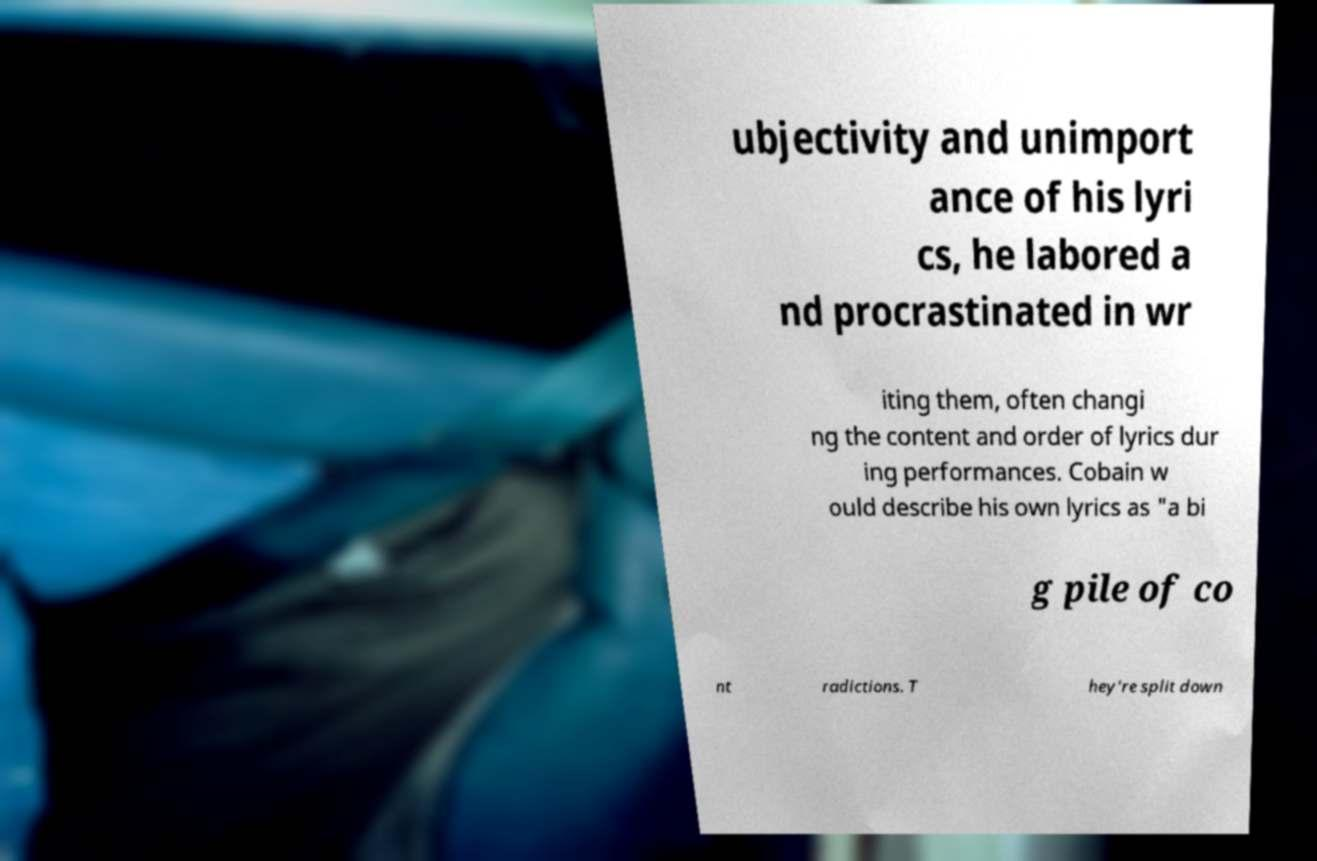Could you extract and type out the text from this image? ubjectivity and unimport ance of his lyri cs, he labored a nd procrastinated in wr iting them, often changi ng the content and order of lyrics dur ing performances. Cobain w ould describe his own lyrics as "a bi g pile of co nt radictions. T hey're split down 